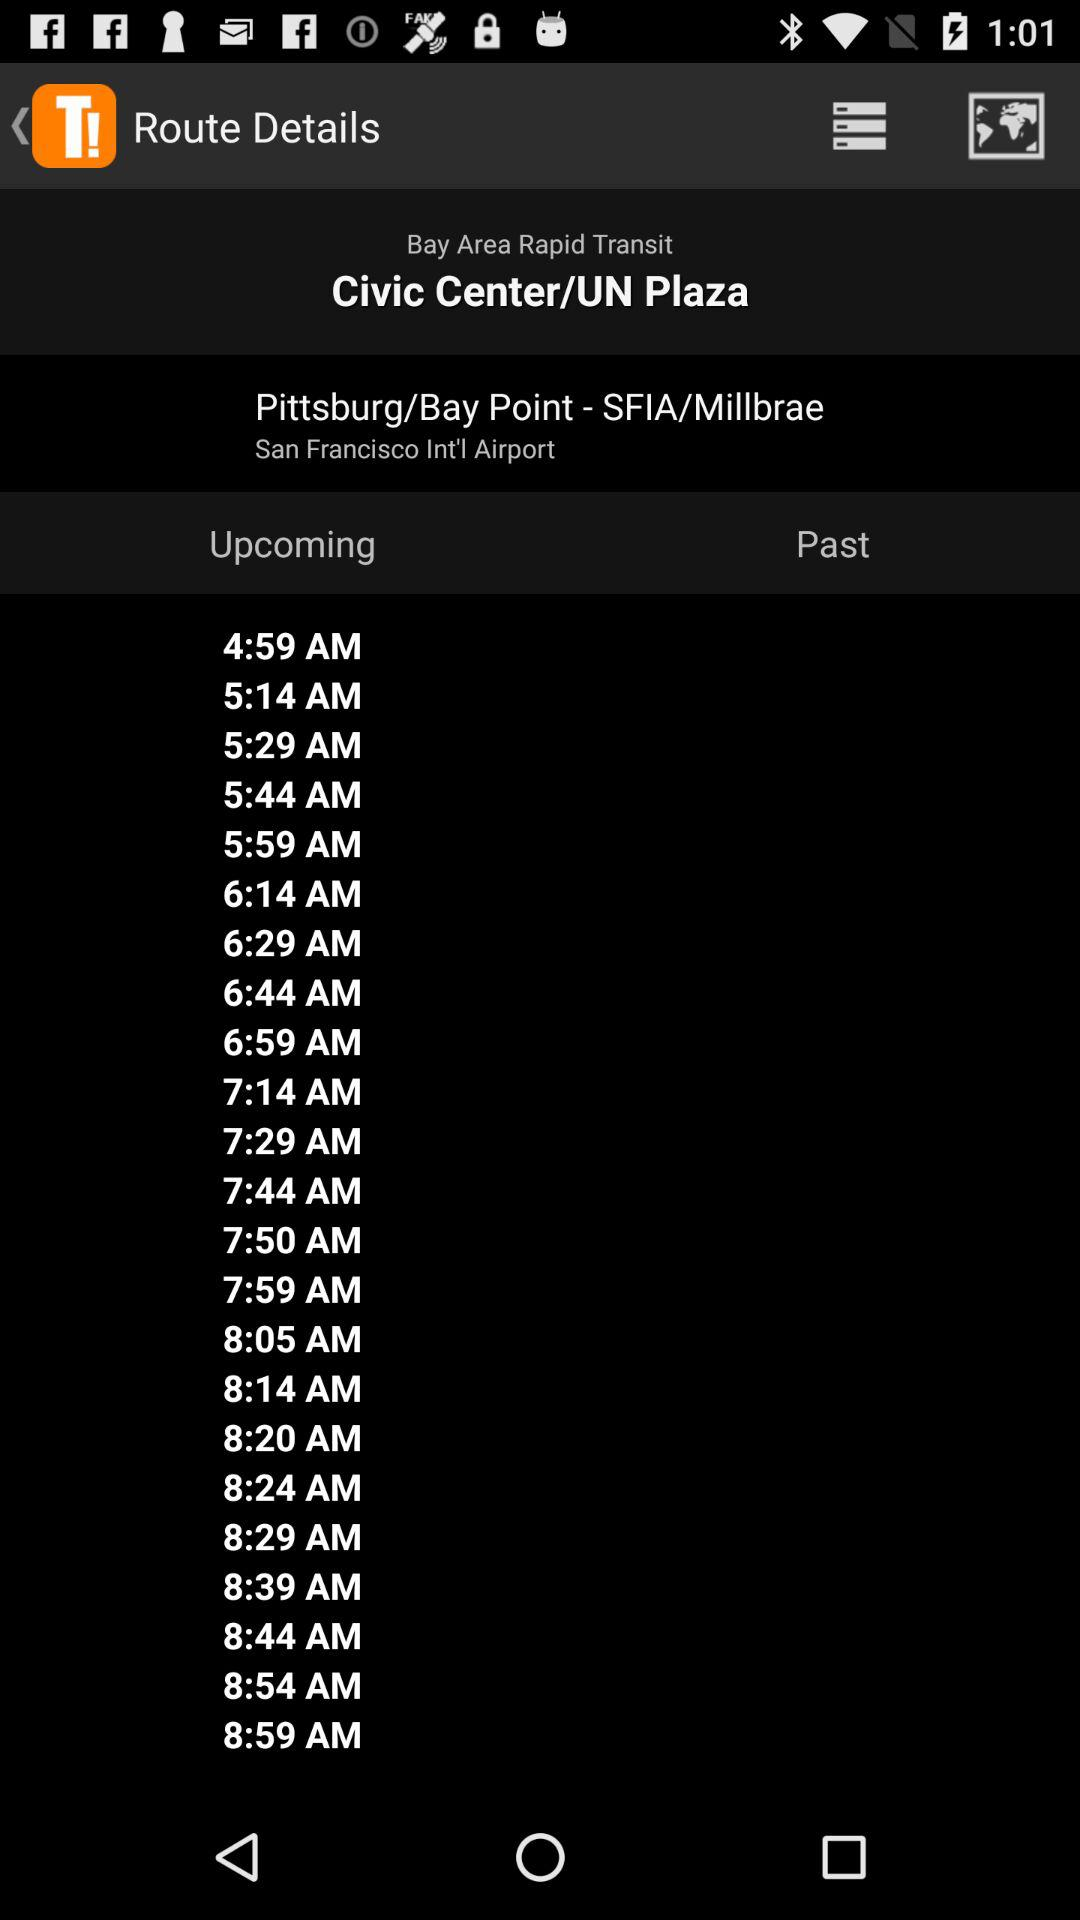What location is shown? The shown locations are Civic Center/UN Plaza, Pittsburg/Bay Point - SFIA/Millbrae and San Francisco International Airport. 